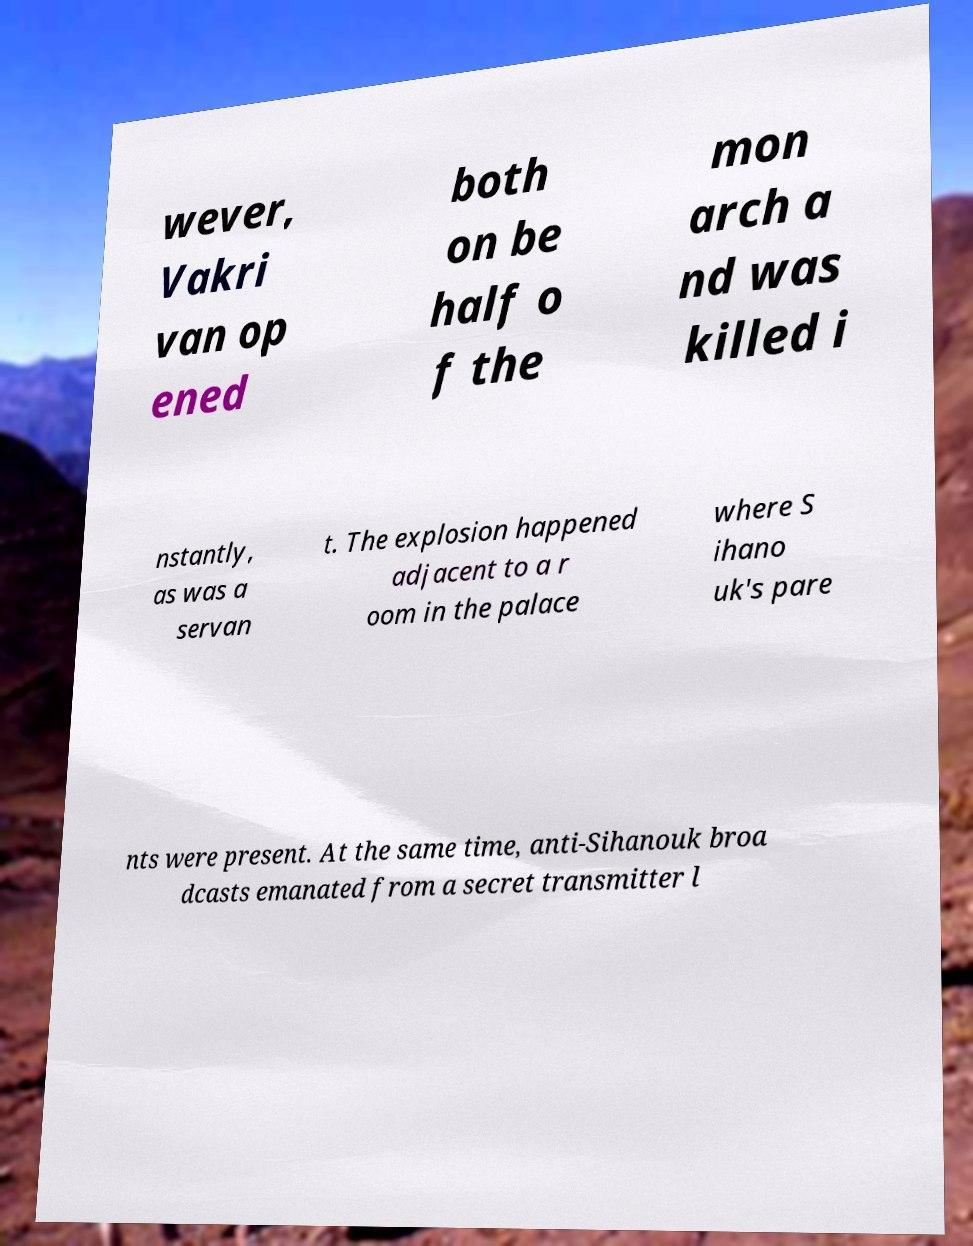There's text embedded in this image that I need extracted. Can you transcribe it verbatim? wever, Vakri van op ened both on be half o f the mon arch a nd was killed i nstantly, as was a servan t. The explosion happened adjacent to a r oom in the palace where S ihano uk's pare nts were present. At the same time, anti-Sihanouk broa dcasts emanated from a secret transmitter l 